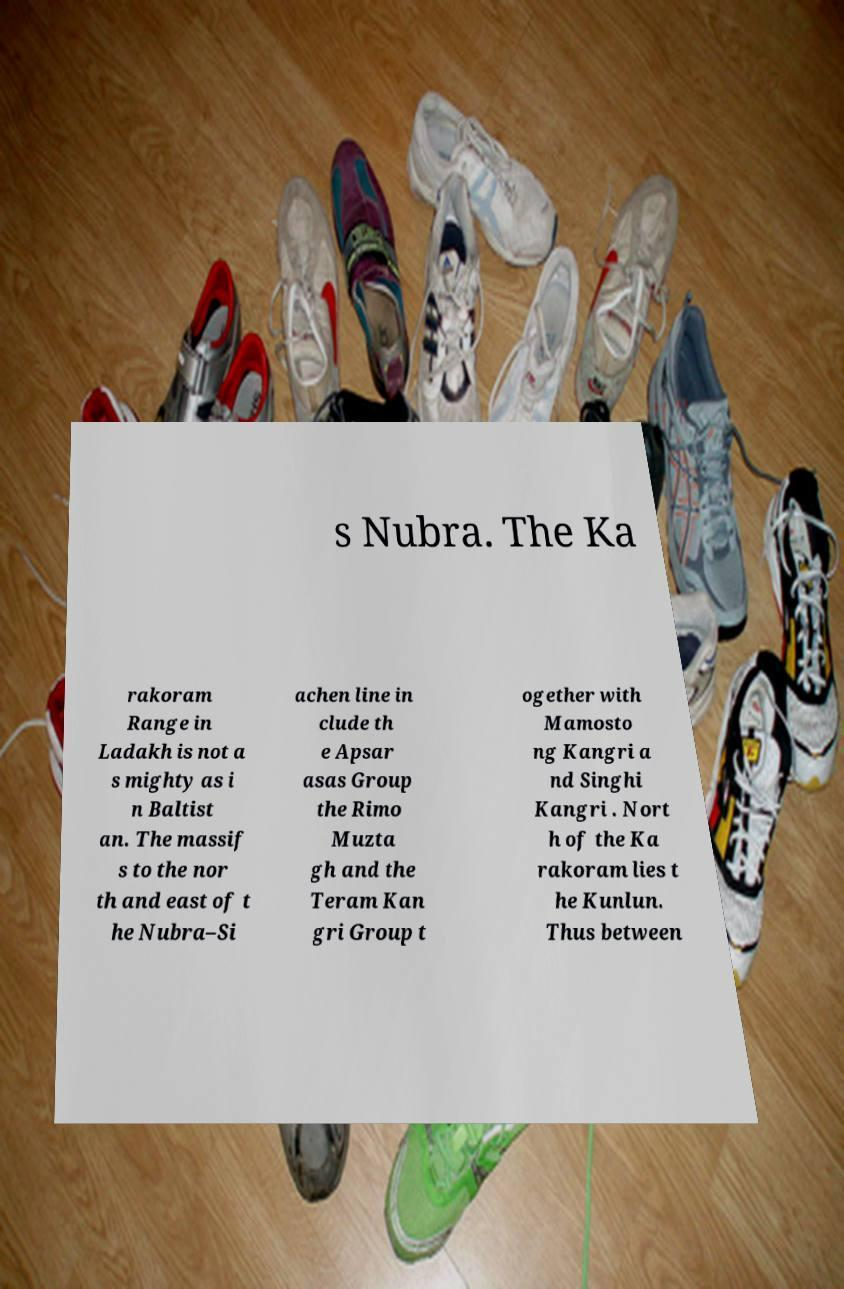I need the written content from this picture converted into text. Can you do that? s Nubra. The Ka rakoram Range in Ladakh is not a s mighty as i n Baltist an. The massif s to the nor th and east of t he Nubra–Si achen line in clude th e Apsar asas Group the Rimo Muzta gh and the Teram Kan gri Group t ogether with Mamosto ng Kangri a nd Singhi Kangri . Nort h of the Ka rakoram lies t he Kunlun. Thus between 